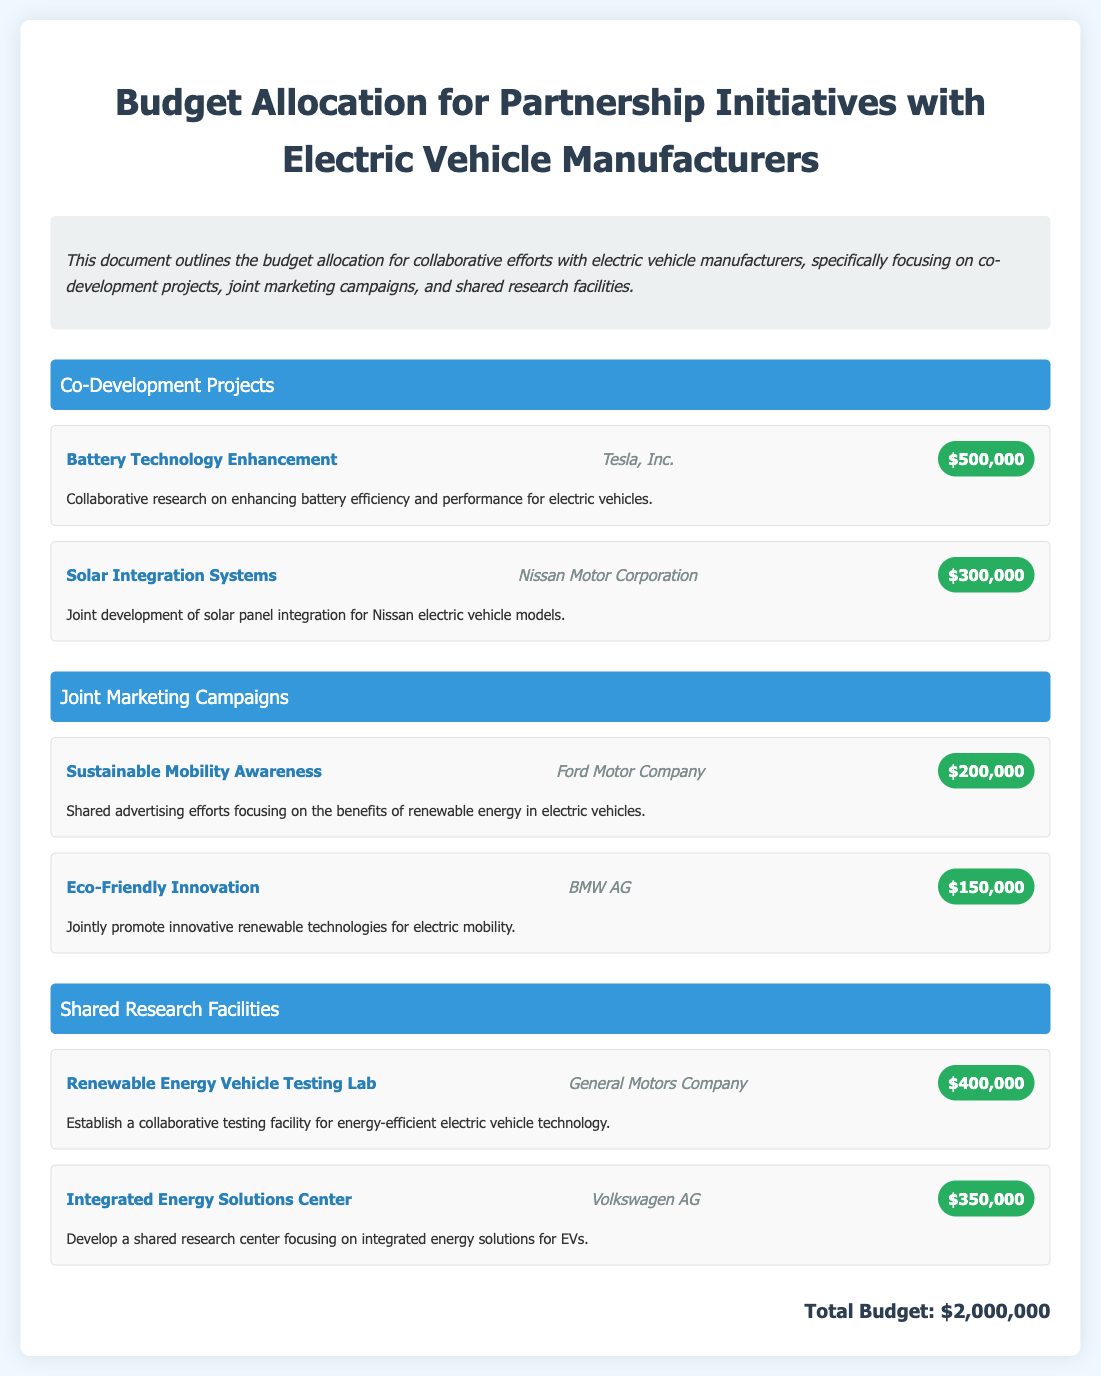what is the total budget? The total budget is stated at the end of the document, summarizing all allocated funds, which is $2,000,000.
Answer: $2,000,000 who are the partners involved in the co-development projects? The co-development projects include partnerships with Tesla, Inc. and Nissan Motor Corporation.
Answer: Tesla, Inc. and Nissan Motor Corporation how much is allocated for the joint marketing campaign with Ford Motor Company? The budget allocation for the project with Ford Motor Company is specifically mentioned as part of the joint marketing campaigns section.
Answer: $200,000 which project involves General Motors Company? The project involving General Motors Company is for establishing a testing lab for energy-efficient electric vehicle technology.
Answer: Renewable Energy Vehicle Testing Lab how much is budgeted for solar integration systems? The budget for solar integration systems is clearly stated in the co-development projects section, specifically linked to Nissan Motor Corporation.
Answer: $300,000 what is the focus of the Integrated Energy Solutions Center? The description indicates that the focus of the Integrated Energy Solutions Center is on developing integrated energy solutions for EVs.
Answer: Integrated energy solutions for EVs how many projects are listed under shared research facilities? The document presents two specific projects within the shared research facilities section.
Answer: Two projects which company is partnering for the Battery Technology Enhancement project? The company partnering for the Battery Technology Enhancement project is explicitly stated in the co-development projects section.
Answer: Tesla, Inc 